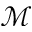<formula> <loc_0><loc_0><loc_500><loc_500>\mathcal { M }</formula> 